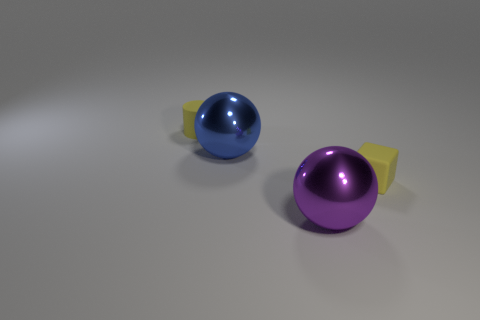Add 3 tiny cyan matte things. How many objects exist? 7 Subtract all blocks. How many objects are left? 3 Add 2 small yellow blocks. How many small yellow blocks exist? 3 Subtract 0 brown cubes. How many objects are left? 4 Subtract all tiny gray matte cubes. Subtract all big blue metallic spheres. How many objects are left? 3 Add 1 yellow rubber things. How many yellow rubber things are left? 3 